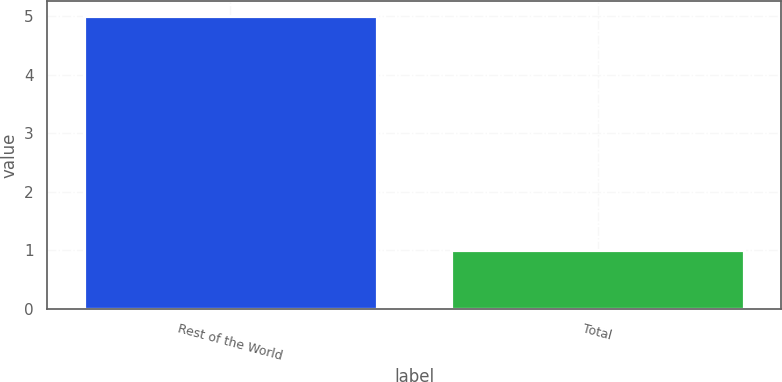Convert chart to OTSL. <chart><loc_0><loc_0><loc_500><loc_500><bar_chart><fcel>Rest of the World<fcel>Total<nl><fcel>5<fcel>1<nl></chart> 